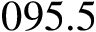Convert formula to latex. <formula><loc_0><loc_0><loc_500><loc_500>0 9 5 . 5</formula> 